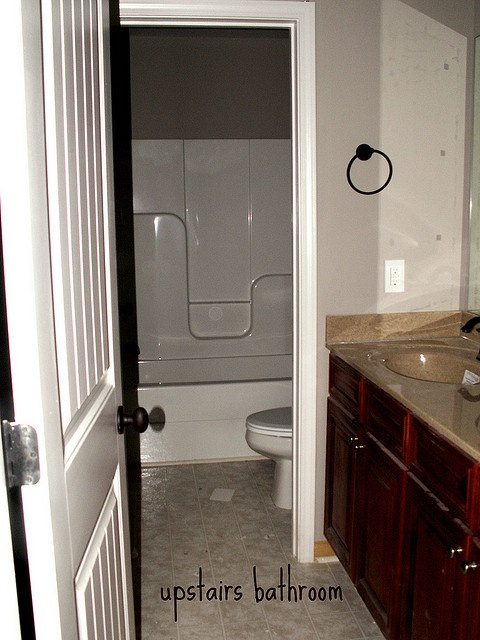Describe the objects in this image and their specific colors. I can see toilet in white, darkgray, and gray tones and sink in white, gray, and darkgray tones in this image. 